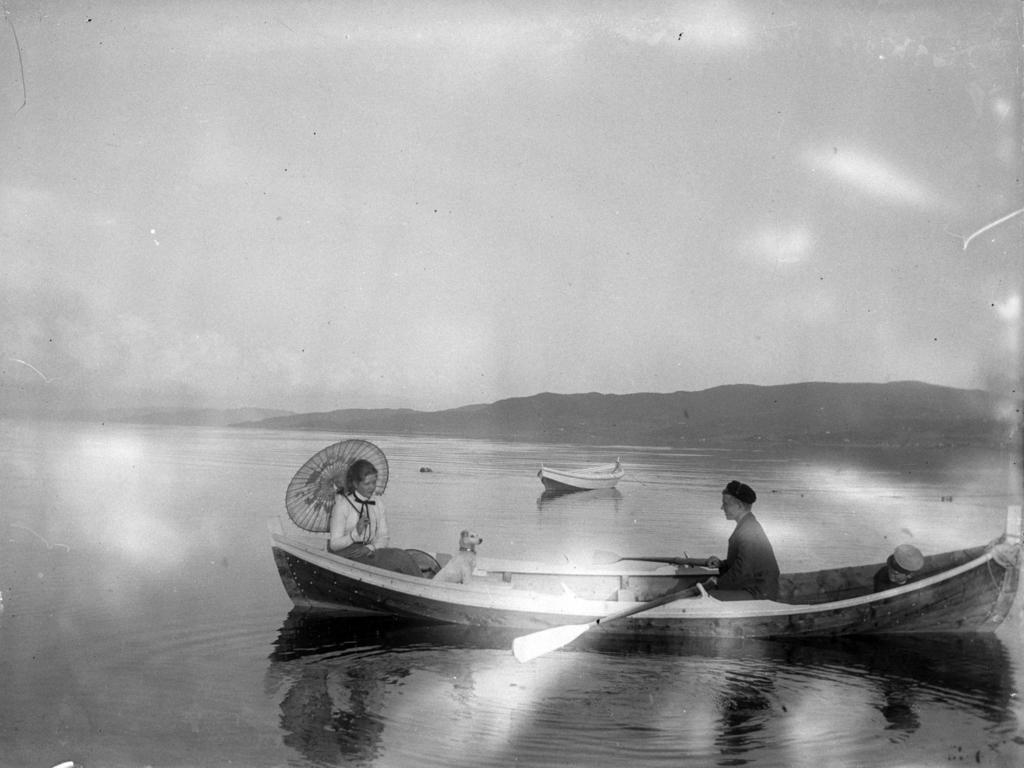Describe this image in one or two sentences. In this picture we can see boats on the water and on a boat we can see two people, dog, paddle, umbrella and in the background we can see mountains and the sky. 